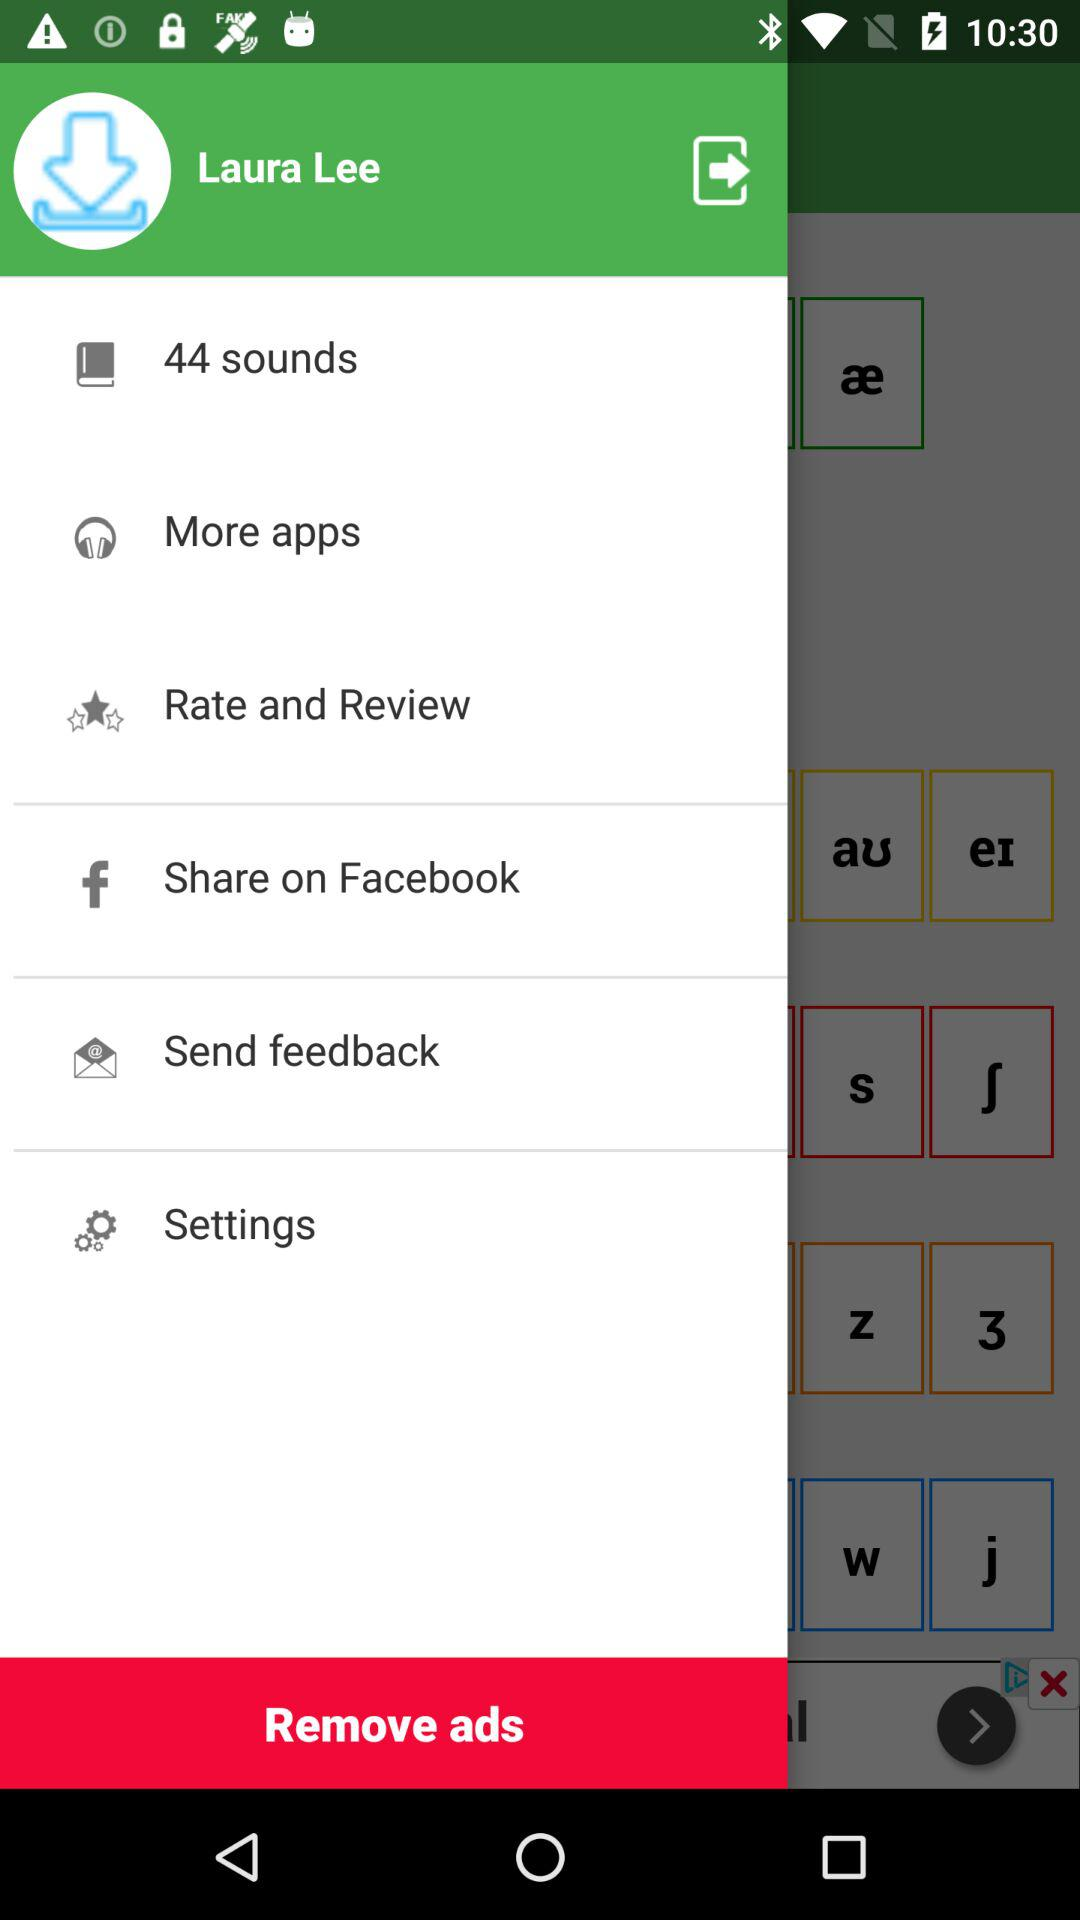How many sounds are there? There are 44 sounds. 